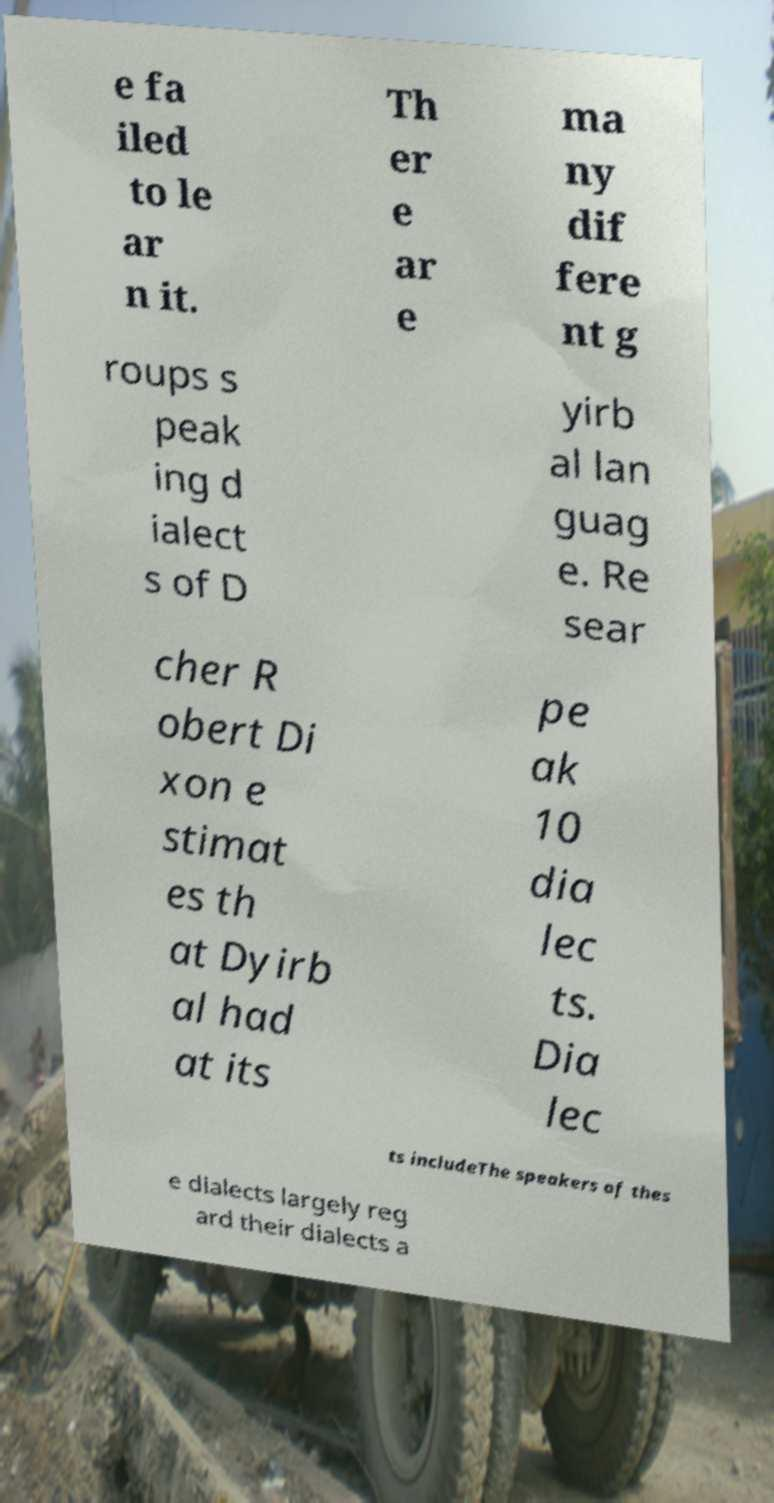Could you extract and type out the text from this image? e fa iled to le ar n it. Th er e ar e ma ny dif fere nt g roups s peak ing d ialect s of D yirb al lan guag e. Re sear cher R obert Di xon e stimat es th at Dyirb al had at its pe ak 10 dia lec ts. Dia lec ts includeThe speakers of thes e dialects largely reg ard their dialects a 